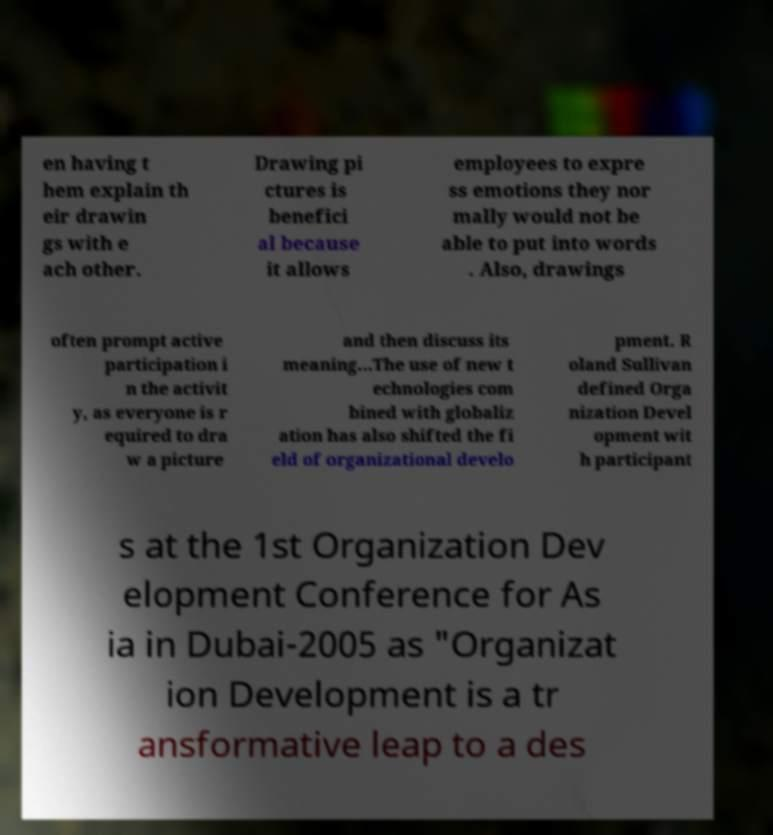There's text embedded in this image that I need extracted. Can you transcribe it verbatim? en having t hem explain th eir drawin gs with e ach other. Drawing pi ctures is benefici al because it allows employees to expre ss emotions they nor mally would not be able to put into words . Also, drawings often prompt active participation i n the activit y, as everyone is r equired to dra w a picture and then discuss its meaning...The use of new t echnologies com bined with globaliz ation has also shifted the fi eld of organizational develo pment. R oland Sullivan defined Orga nization Devel opment wit h participant s at the 1st Organization Dev elopment Conference for As ia in Dubai-2005 as "Organizat ion Development is a tr ansformative leap to a des 